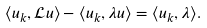Convert formula to latex. <formula><loc_0><loc_0><loc_500><loc_500>\langle u _ { k } , \mathcal { L } u \rangle - \langle u _ { k } , \lambda u \rangle = \langle u _ { k } , \lambda \rangle .</formula> 